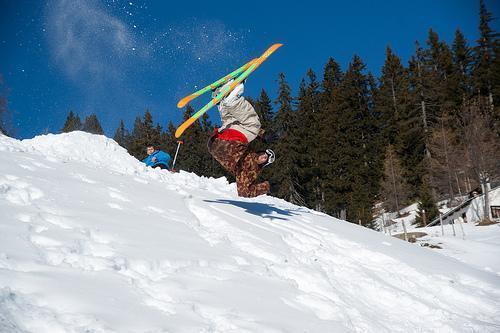How many people are there?
Give a very brief answer. 2. 